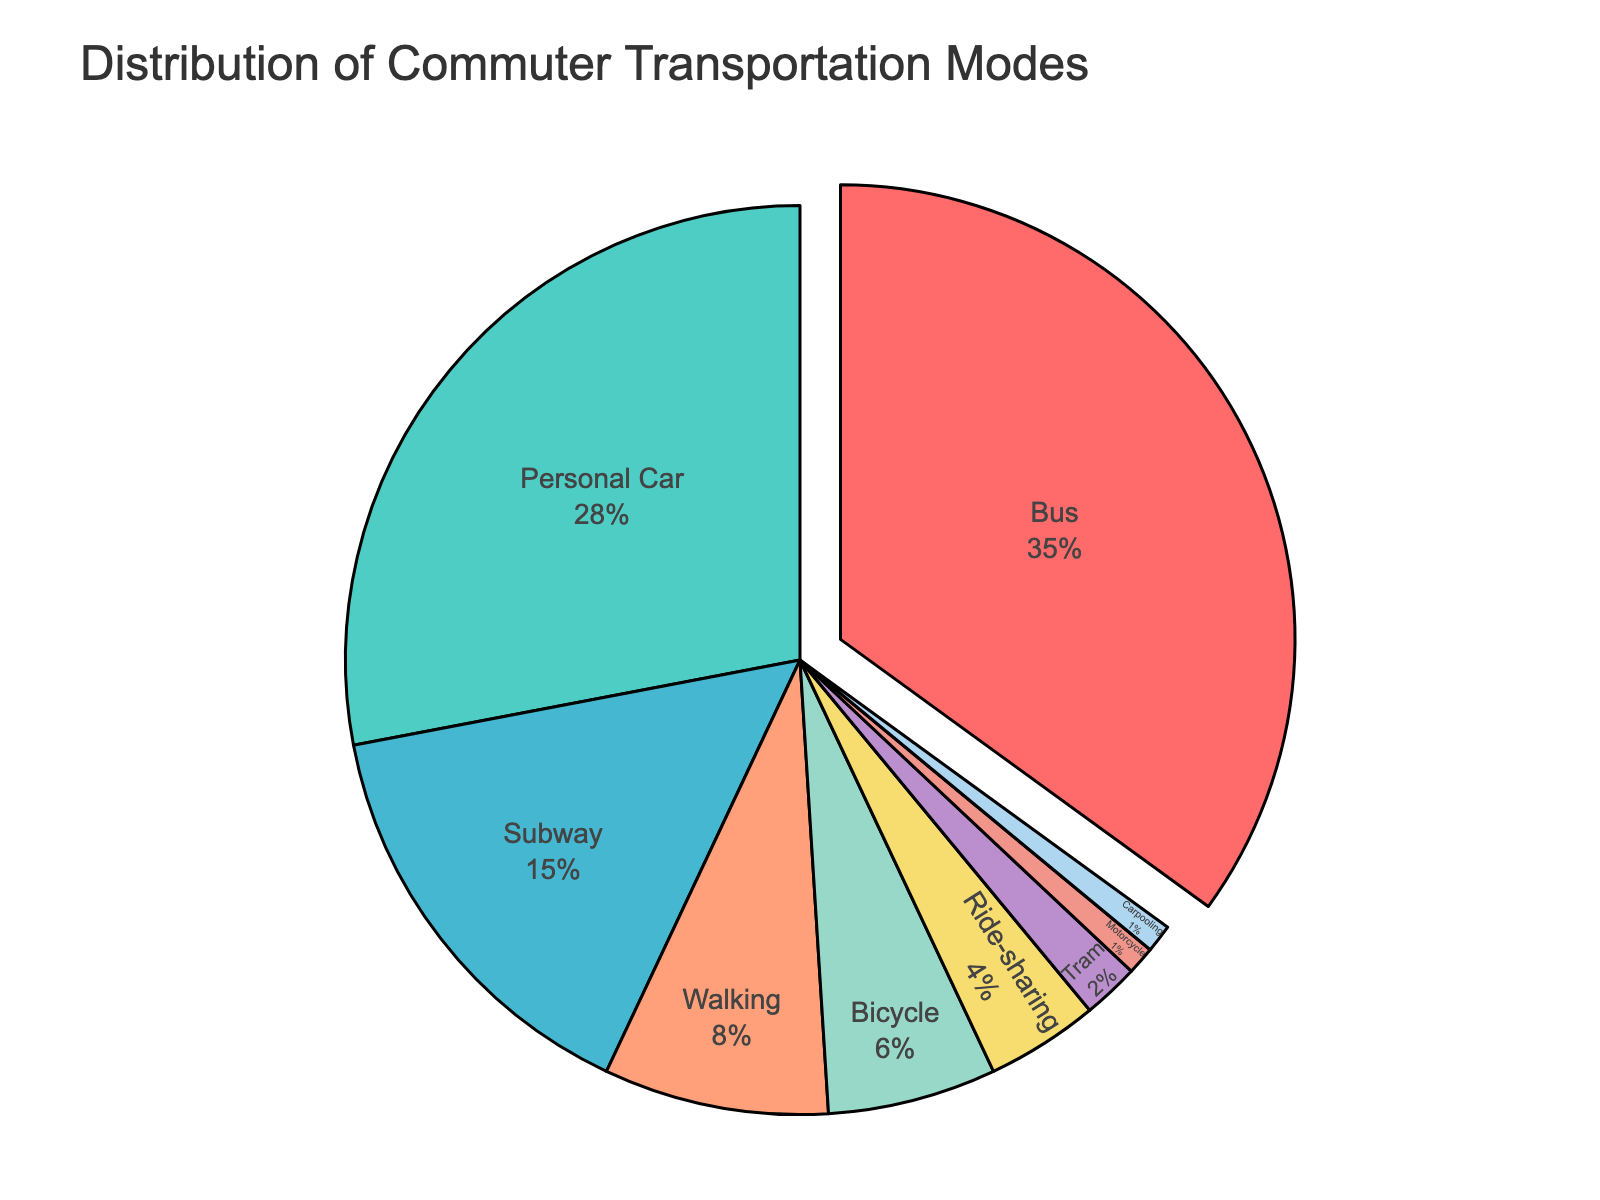Which transportation mode is used by the majority of commuters? Look for the mode with the largest portion in the pie chart. "Bus" has the largest portion with 35%.
Answer: Bus What percentage of commuters use public transportation modes (Bus, Subway, Tram)? Sum up the percentages of Bus, Subway, and Tram modes. Bus (35%) + Subway (15%) + Tram (2%) = 52%.
Answer: 52% How does the percentage of people using ride-sharing compare to those using a bicycle? Examine the respective percentages in the pie chart. Ride-sharing is 4% and Bicycle is 6%.
Answer: Bicycle is 2% higher What is the combined percentage of commuters using Personal Car and Carpooling? Add the percentages of Personal Car and Carpooling modes. Personal Car (28%) + Carpooling (1%) = 29%.
Answer: 29% Which transportation mode has the smallest percentage? Identify the smallest slice in the pie chart. Motorcycle and Carpooling both have 1%.
Answer: Motorcycle and Carpooling What is the difference in percentage between those who walk and those who use motorcycles? Subtract the motorcycle percentage from the walking percentage. Walking (8%) - Motorcycle (1%) = 7%.
Answer: 7% If you combine the percentages of non-motorized transportation modes (Walking, Bicycle) and compare with the Bus mode alone, which is higher? Add the Walking and Bicycle percentages, and compare with Bus. Walking (8%) + Bicycle (6%) = 14%. Bus is 35%.
Answer: Bus mode is higher by 21% What can be inferred about the popularity of personal transportation (Personal Car, Motorcycle, Carpooling) compared to public transportation (Bus, Subway, Tram)? Sum the percentages of personal transportation and compare it with the sum of public transportation. Personal: Car (28%) + Motorcycle (1%) + Carpooling (1%) = 30%. Public: Bus (35%) + Subway (15%) + Tram (2%) = 52%.
Answer: Public transportation is more popular How does the use of ride-sharing compare to the use of trams? Look for the percentages of both transportation modes in the pie chart. Ride-sharing is 4%, Tram is 2%.
Answer: Ride-sharing is 2% higher Is walking more popular than using a bicycle among commuters? Examine the respective percentages in the pie chart. Walking is 8%, Bicycle is 6%.
Answer: Yes, walking is more popular 